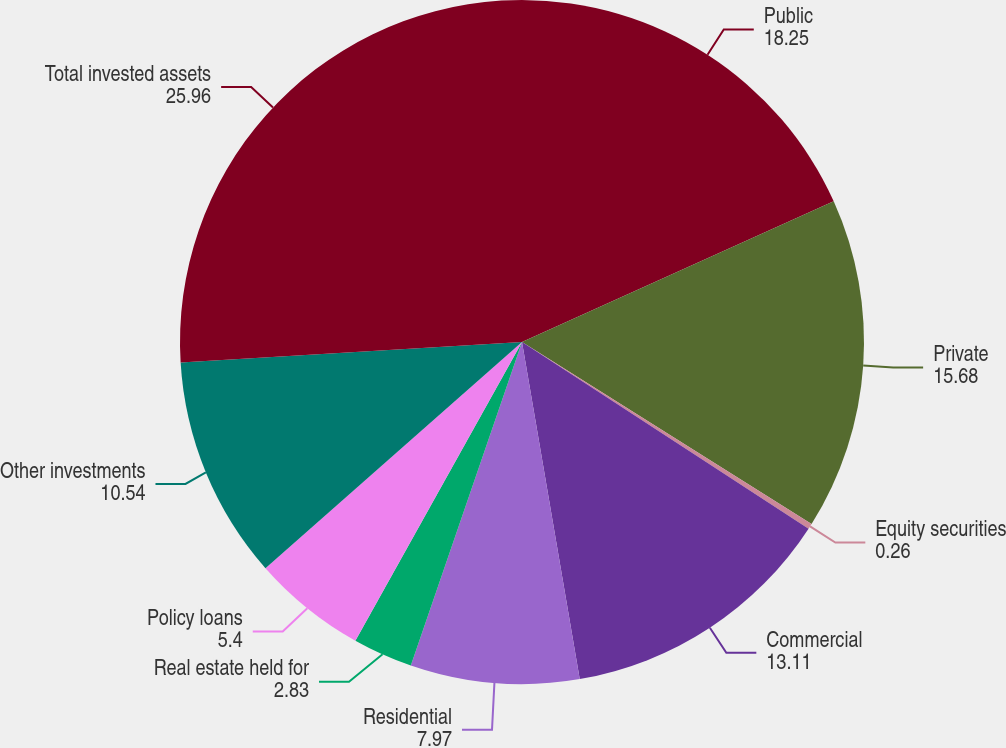<chart> <loc_0><loc_0><loc_500><loc_500><pie_chart><fcel>Public<fcel>Private<fcel>Equity securities<fcel>Commercial<fcel>Residential<fcel>Real estate held for<fcel>Policy loans<fcel>Other investments<fcel>Total invested assets<nl><fcel>18.25%<fcel>15.68%<fcel>0.26%<fcel>13.11%<fcel>7.97%<fcel>2.83%<fcel>5.4%<fcel>10.54%<fcel>25.96%<nl></chart> 